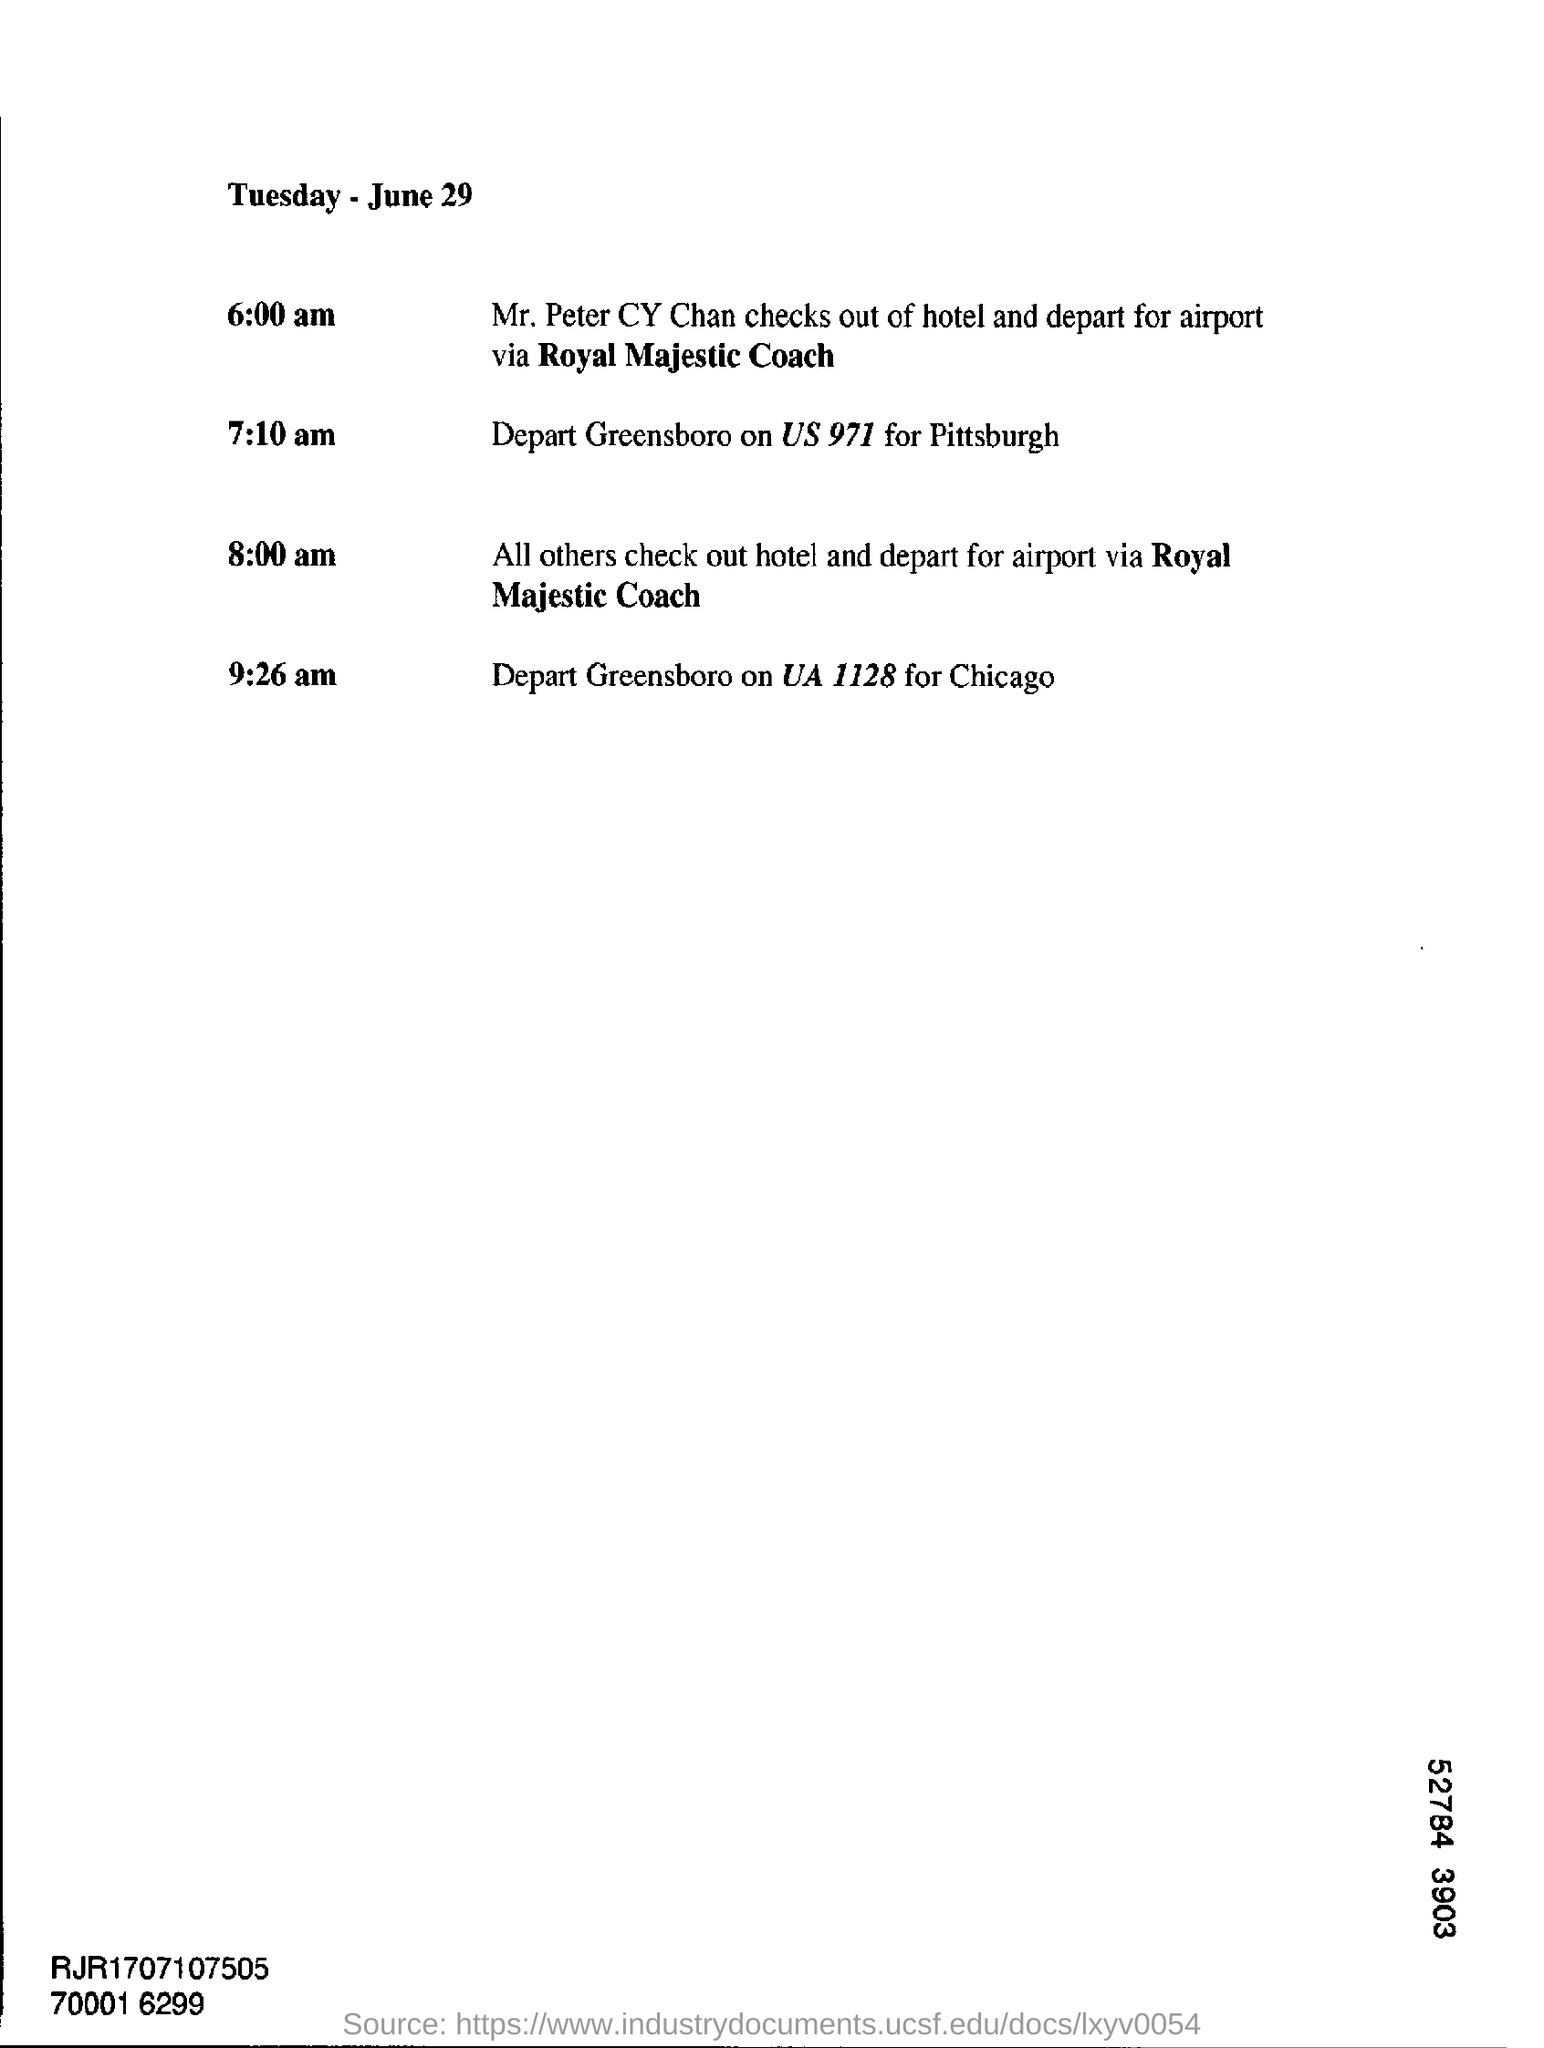What day is June 29 as per this document?
Keep it short and to the point. Tuesday. What time Mr. Peter CY chan checks out from hotel
Provide a short and direct response. 6:00 am. To what place from Hotel Mr. Peter had gone?
Provide a short and direct response. Airport. What time US 971 departs to Pittsburg?
Keep it short and to the point. 7:10 am. What time Greensboro will depart ?
Ensure brevity in your answer.  9:26 am. 